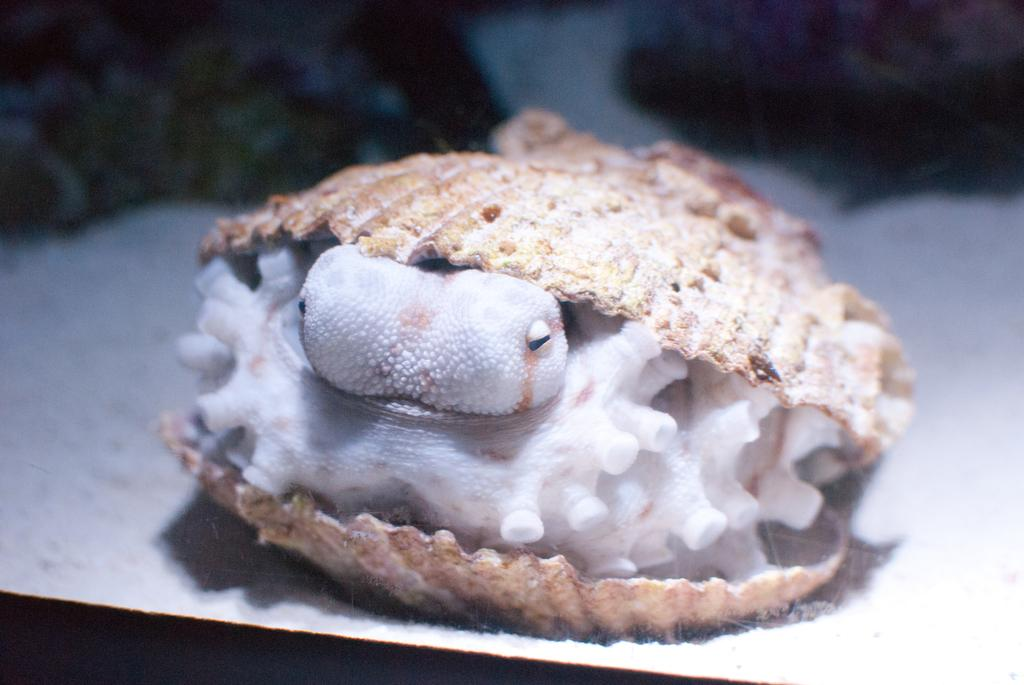What type of sea creature is in the image? There is a shellfish in the image. How is the shellfish protected in the image? The shellfish is inside a shell. What type of surface is the shell resting on in the image? The shell is on the sand. Can you see any cobwebs near the shellfish in the image? There is no mention of cobwebs in the image, so it cannot be determined if any are present. 